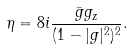Convert formula to latex. <formula><loc_0><loc_0><loc_500><loc_500>\eta = 8 i \frac { \bar { g } g _ { z } } { ( 1 - | g | ^ { 2 } ) ^ { 2 } } .</formula> 